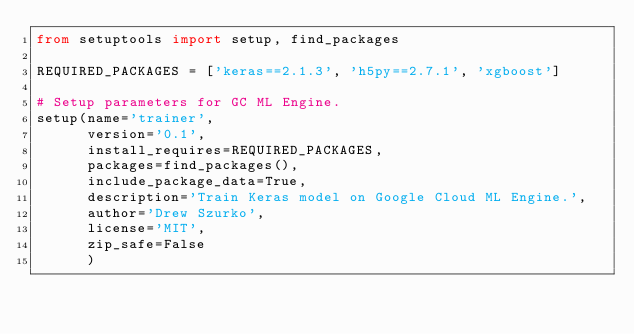<code> <loc_0><loc_0><loc_500><loc_500><_Python_>from setuptools import setup, find_packages

REQUIRED_PACKAGES = ['keras==2.1.3', 'h5py==2.7.1', 'xgboost']

# Setup parameters for GC ML Engine.
setup(name='trainer',
      version='0.1',
      install_requires=REQUIRED_PACKAGES,
      packages=find_packages(),
      include_package_data=True,
      description='Train Keras model on Google Cloud ML Engine.',
      author='Drew Szurko',
      license='MIT',
      zip_safe=False
      )
</code> 